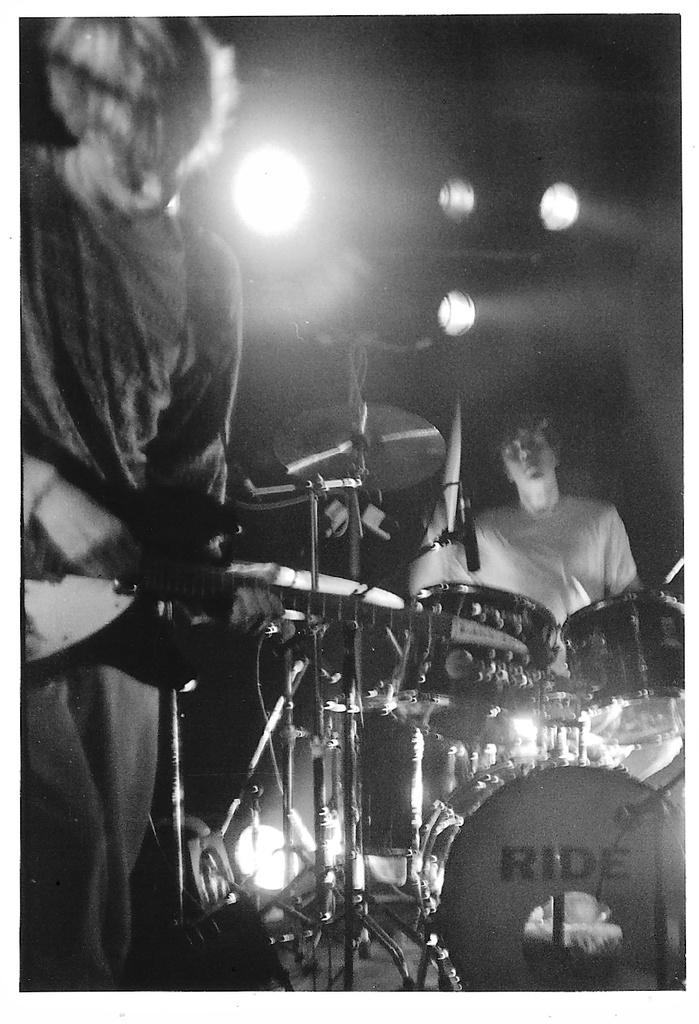How many people are in the image? There are two persons in the image. What is one person doing in the image? One person is playing a guitar. What musical instruments are present in the image besides the guitar? There are drums and cymbals in the image. What can be seen in the background of the image? There are lights in the background of the image. What type of hill can be seen in the background of the image? There is no hill visible in the image; the background features lights. How many days of the week are depicted in the image? The image does not depict any days of the week; it shows two people playing musical instruments. 